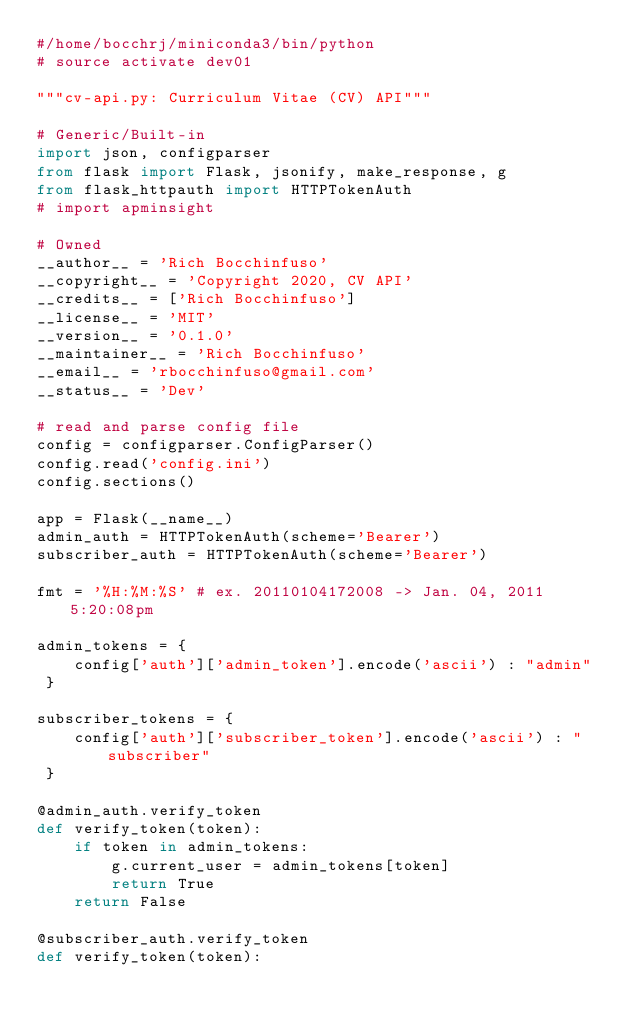Convert code to text. <code><loc_0><loc_0><loc_500><loc_500><_Python_>#/home/bocchrj/miniconda3/bin/python
# source activate dev01

"""cv-api.py: Curriculum Vitae (CV) API"""

# Generic/Built-in
import json, configparser
from flask import Flask, jsonify, make_response, g
from flask_httpauth import HTTPTokenAuth
# import apminsight

# Owned
__author__ = 'Rich Bocchinfuso'
__copyright__ = 'Copyright 2020, CV API'
__credits__ = ['Rich Bocchinfuso']
__license__ = 'MIT'
__version__ = '0.1.0'
__maintainer__ = 'Rich Bocchinfuso'
__email__ = 'rbocchinfuso@gmail.com'
__status__ = 'Dev'

# read and parse config file
config = configparser.ConfigParser()
config.read('config.ini')
config.sections()

app = Flask(__name__)
admin_auth = HTTPTokenAuth(scheme='Bearer')
subscriber_auth = HTTPTokenAuth(scheme='Bearer')

fmt = '%H:%M:%S' # ex. 20110104172008 -> Jan. 04, 2011 5:20:08pm 

admin_tokens = {
    config['auth']['admin_token'].encode('ascii') : "admin"
 }

subscriber_tokens = {
    config['auth']['subscriber_token'].encode('ascii') : "subscriber"
 }
 
@admin_auth.verify_token
def verify_token(token):
    if token in admin_tokens:
        g.current_user = admin_tokens[token]
        return True
    return False
    
@subscriber_auth.verify_token
def verify_token(token):</code> 